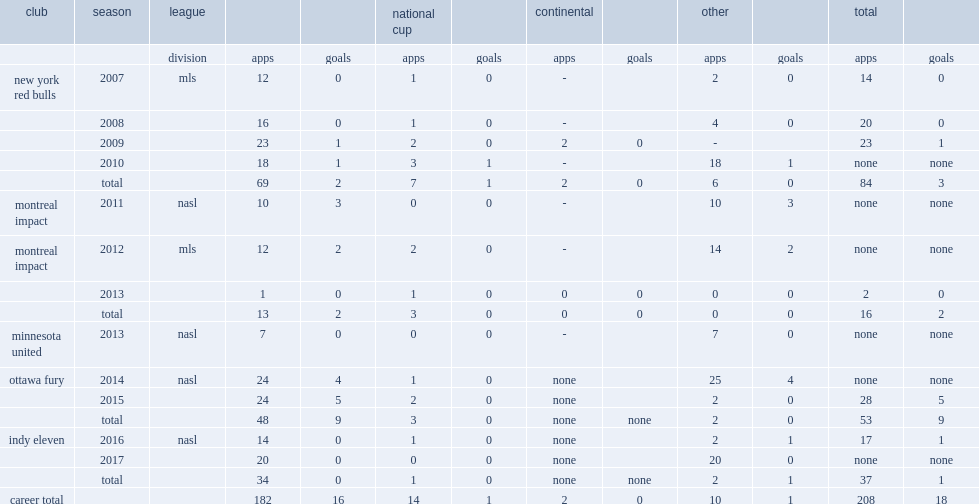Which club did ubiparipovic play for in 2014? Ottawa fury. Can you give me this table as a dict? {'header': ['club', 'season', 'league', '', '', 'national cup', '', 'continental', '', 'other', '', 'total', ''], 'rows': [['', '', 'division', 'apps', 'goals', 'apps', 'goals', 'apps', 'goals', 'apps', 'goals', 'apps', 'goals'], ['new york red bulls', '2007', 'mls', '12', '0', '1', '0', '-', '', '2', '0', '14', '0'], ['', '2008', '', '16', '0', '1', '0', '-', '', '4', '0', '20', '0'], ['', '2009', '', '23', '1', '2', '0', '2', '0', '-', '', '23', '1'], ['', '2010', '', '18', '1', '3', '1', '-', '', '18', '1', 'none', 'none'], ['', 'total', '', '69', '2', '7', '1', '2', '0', '6', '0', '84', '3'], ['montreal impact', '2011', 'nasl', '10', '3', '0', '0', '-', '', '10', '3', 'none', 'none'], ['montreal impact', '2012', 'mls', '12', '2', '2', '0', '-', '', '14', '2', 'none', 'none'], ['', '2013', '', '1', '0', '1', '0', '0', '0', '0', '0', '2', '0'], ['', 'total', '', '13', '2', '3', '0', '0', '0', '0', '0', '16', '2'], ['minnesota united', '2013', 'nasl', '7', '0', '0', '0', '-', '', '7', '0', 'none', 'none'], ['ottawa fury', '2014', 'nasl', '24', '4', '1', '0', 'none', '', '25', '4', 'none', 'none'], ['', '2015', '', '24', '5', '2', '0', 'none', '', '2', '0', '28', '5'], ['', 'total', '', '48', '9', '3', '0', 'none', 'none', '2', '0', '53', '9'], ['indy eleven', '2016', 'nasl', '14', '0', '1', '0', 'none', '', '2', '1', '17', '1'], ['', '2017', '', '20', '0', '0', '0', 'none', '', '20', '0', 'none', 'none'], ['', 'total', '', '34', '0', '1', '0', 'none', 'none', '2', '1', '37', '1'], ['career total', '', '', '182', '16', '14', '1', '2', '0', '10', '1', '208', '18']]} 